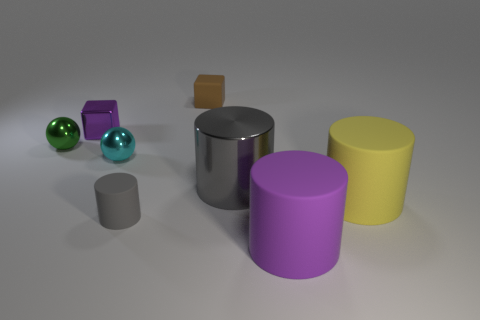Add 2 gray metallic things. How many objects exist? 10 Subtract all blocks. How many objects are left? 6 Subtract 0 yellow spheres. How many objects are left? 8 Subtract all gray matte cylinders. Subtract all small green spheres. How many objects are left? 6 Add 8 purple shiny things. How many purple shiny things are left? 9 Add 2 green objects. How many green objects exist? 3 